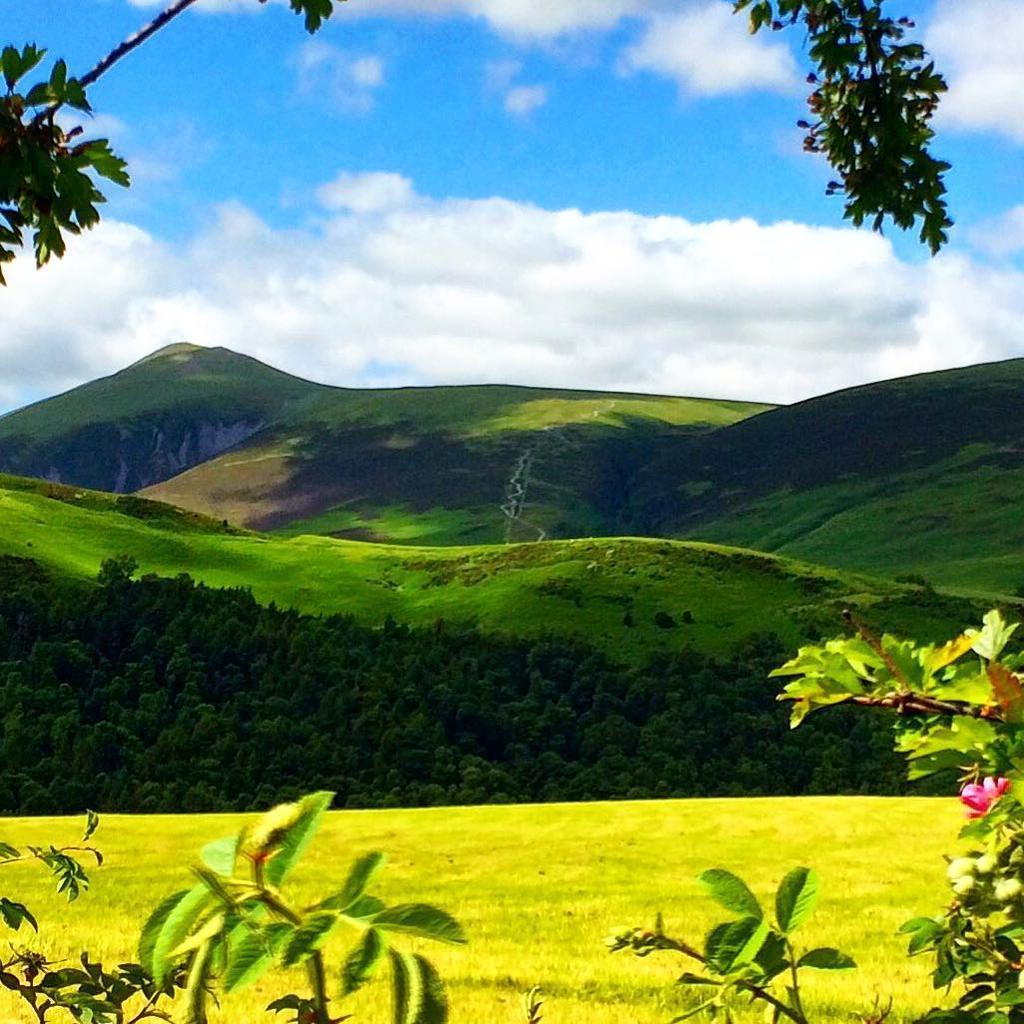In one or two sentences, can you explain what this image depicts? In the picture we can see a grass surface with some plants near it and far away we can see trees, hills and the hills are covered with grass and in the background we can see a sky with clouds. 